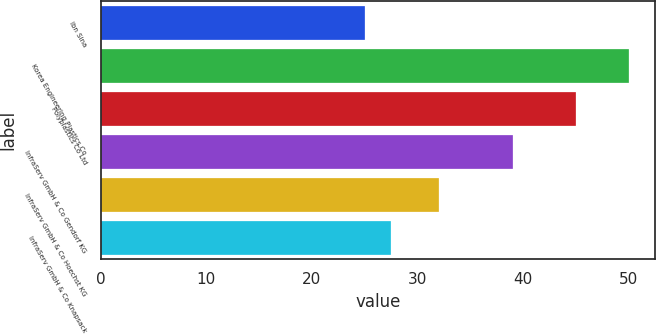Convert chart to OTSL. <chart><loc_0><loc_0><loc_500><loc_500><bar_chart><fcel>Ibn Sina<fcel>Korea Engineering Plastics Co<fcel>Polyplastics Co Ltd<fcel>InfraServ GmbH & Co Gendorf KG<fcel>InfraServ GmbH & Co Hoechst KG<fcel>InfraServ GmbH & Co Knapsack<nl><fcel>25<fcel>50<fcel>45<fcel>39<fcel>32<fcel>27.5<nl></chart> 